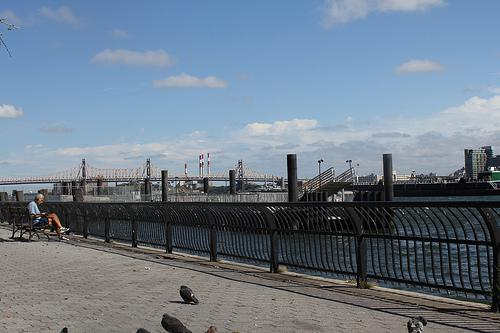Question: what is gender of person?
Choices:
A. Female.
B. One of each.
C. Hard to tell.
D. Male.
Answer with the letter. Answer: D Question: what is in the foreground?
Choices:
A. Dogs.
B. Cats.
C. Birds.
D. Elephants.
Answer with the letter. Answer: C Question: who is in the picture?
Choices:
A. One person.
B. Man.
C. Woman.
D. Two children.
Answer with the letter. Answer: A Question: when was picture taken?
Choices:
A. During daylight.
B. Night.
C. Noon.
D. Evening.
Answer with the letter. Answer: A 